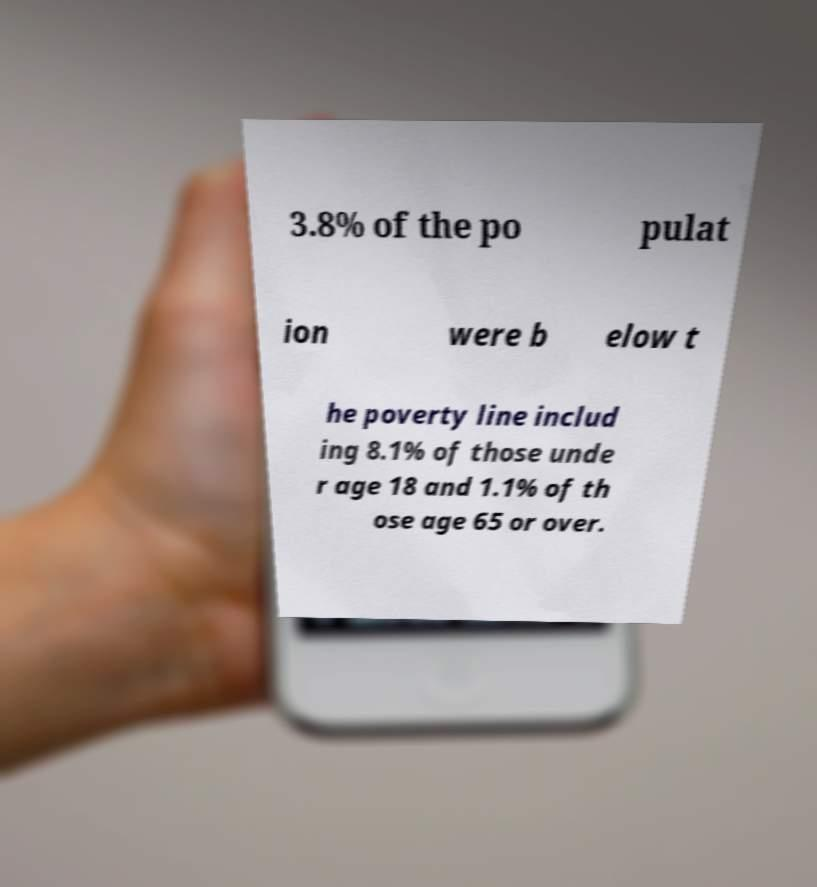Could you assist in decoding the text presented in this image and type it out clearly? 3.8% of the po pulat ion were b elow t he poverty line includ ing 8.1% of those unde r age 18 and 1.1% of th ose age 65 or over. 